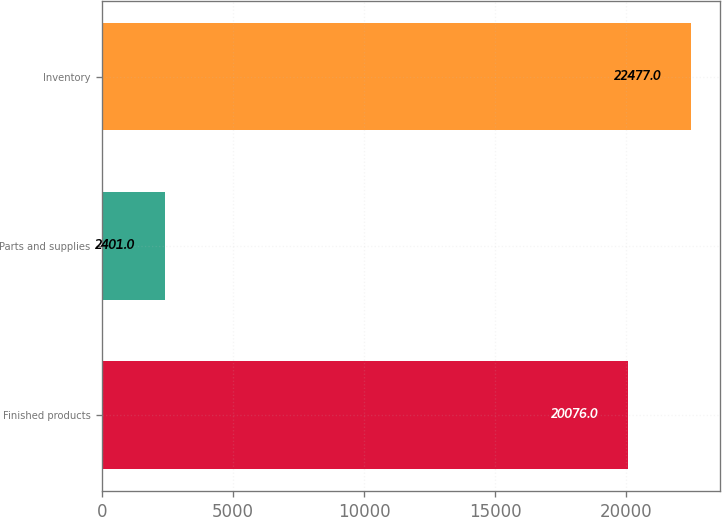<chart> <loc_0><loc_0><loc_500><loc_500><bar_chart><fcel>Finished products<fcel>Parts and supplies<fcel>Inventory<nl><fcel>20076<fcel>2401<fcel>22477<nl></chart> 